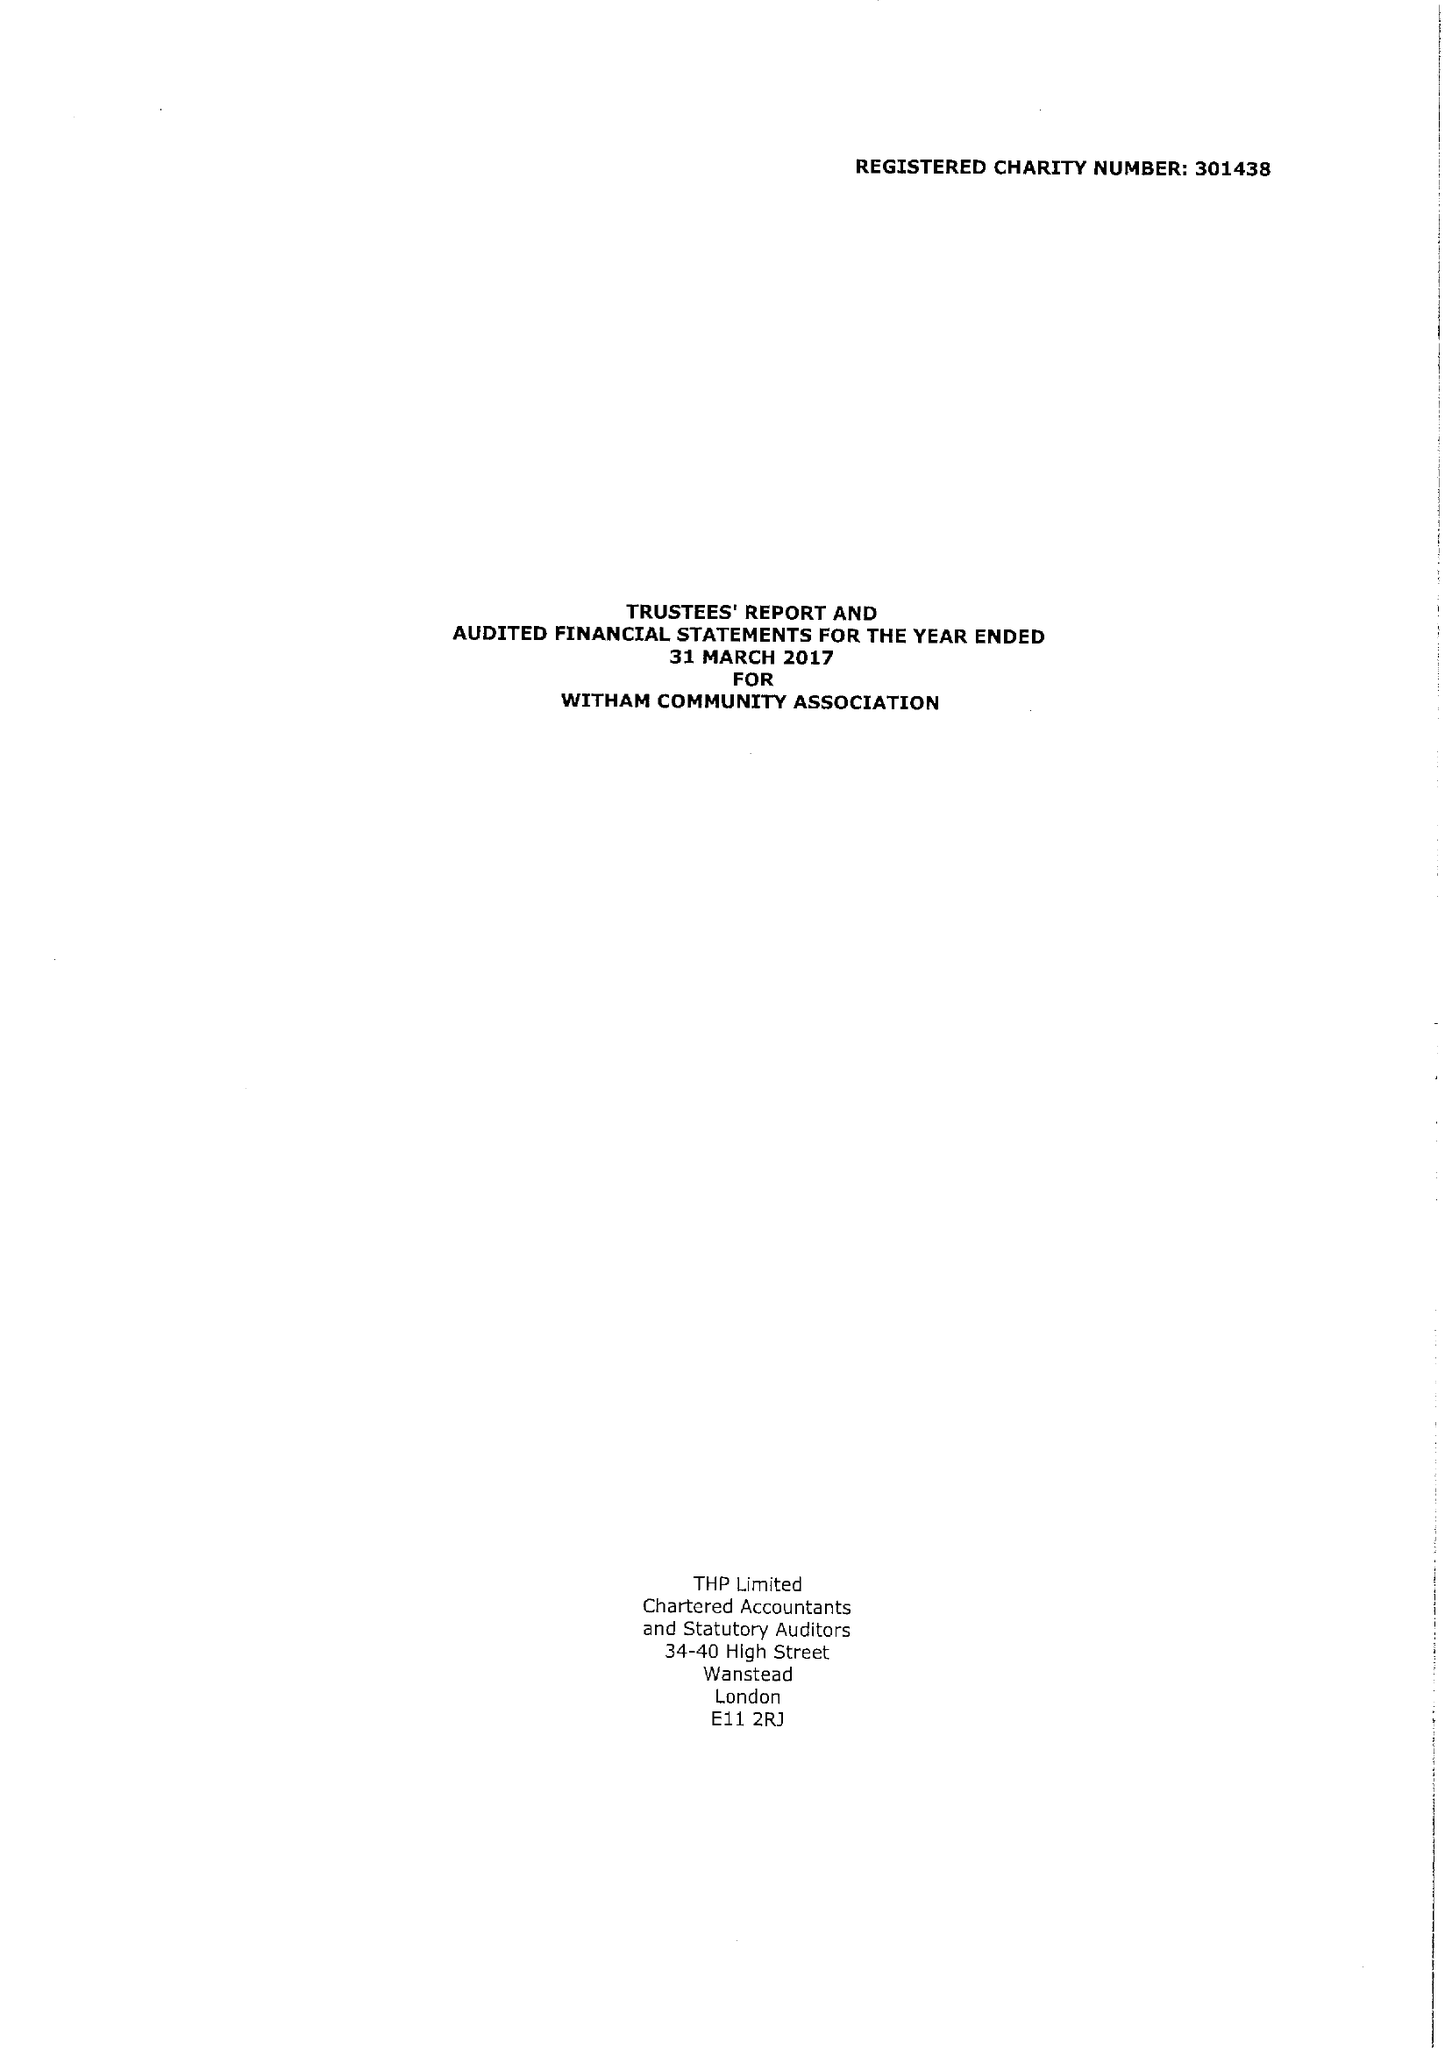What is the value for the income_annually_in_british_pounds?
Answer the question using a single word or phrase. 186732.00 